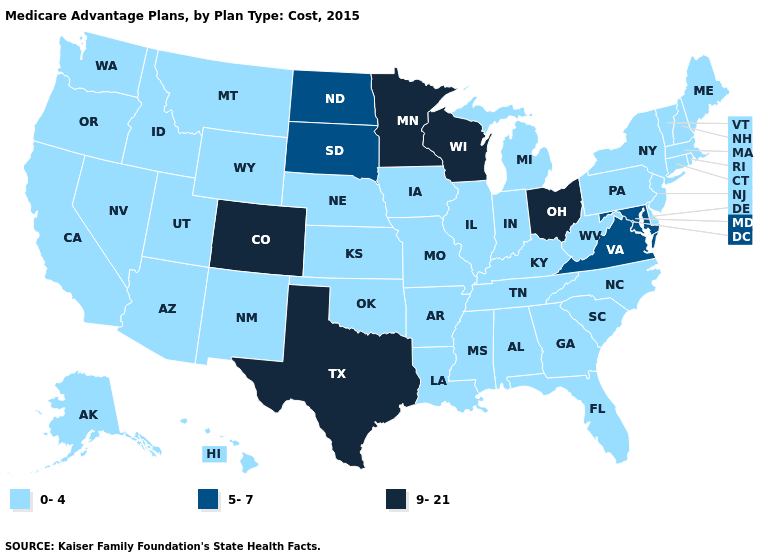Does the map have missing data?
Answer briefly. No. Name the states that have a value in the range 0-4?
Answer briefly. Alaska, Alabama, Arkansas, Arizona, California, Connecticut, Delaware, Florida, Georgia, Hawaii, Iowa, Idaho, Illinois, Indiana, Kansas, Kentucky, Louisiana, Massachusetts, Maine, Michigan, Missouri, Mississippi, Montana, North Carolina, Nebraska, New Hampshire, New Jersey, New Mexico, Nevada, New York, Oklahoma, Oregon, Pennsylvania, Rhode Island, South Carolina, Tennessee, Utah, Vermont, Washington, West Virginia, Wyoming. What is the lowest value in the USA?
Answer briefly. 0-4. Does Colorado have the lowest value in the USA?
Quick response, please. No. What is the lowest value in the USA?
Answer briefly. 0-4. Does Florida have the highest value in the USA?
Be succinct. No. What is the value of Maryland?
Keep it brief. 5-7. Does Colorado have the highest value in the West?
Concise answer only. Yes. Does Colorado have the highest value in the West?
Write a very short answer. Yes. What is the value of North Dakota?
Be succinct. 5-7. What is the highest value in states that border Vermont?
Be succinct. 0-4. What is the lowest value in states that border Idaho?
Keep it brief. 0-4. Which states hav the highest value in the MidWest?
Keep it brief. Minnesota, Ohio, Wisconsin. 